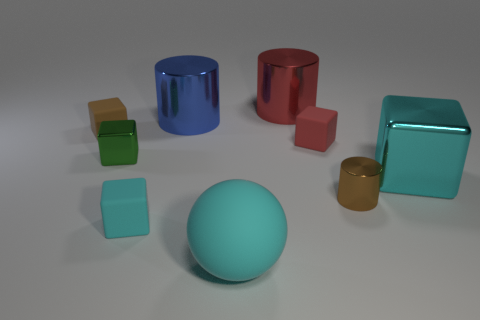The matte block that is the same color as the big matte object is what size?
Provide a short and direct response. Small. Is there a cube that is left of the cyan cube that is on the right side of the small rubber object in front of the green object?
Ensure brevity in your answer.  Yes. Are there any red things behind the blue object?
Your response must be concise. Yes. What number of big metal objects are on the right side of the shiny block that is in front of the green metallic block?
Give a very brief answer. 0. Does the cyan matte block have the same size as the cyan metal thing that is on the right side of the tiny brown shiny object?
Your answer should be very brief. No. Is there a tiny metal object of the same color as the tiny cylinder?
Your answer should be compact. No. What size is the red cube that is the same material as the small cyan object?
Ensure brevity in your answer.  Small. Is the material of the green block the same as the small brown cylinder?
Your response must be concise. Yes. What is the color of the large thing that is to the right of the red cylinder that is behind the large cyan object that is in front of the big block?
Provide a succinct answer. Cyan. What shape is the cyan metallic object?
Make the answer very short. Cube. 